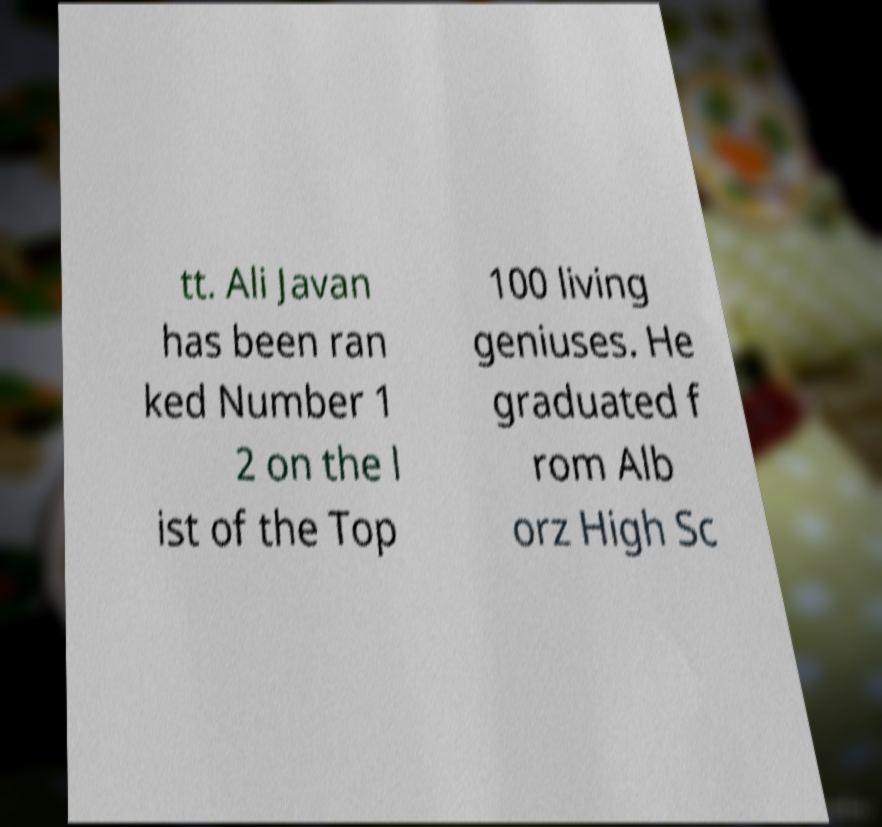Can you accurately transcribe the text from the provided image for me? tt. Ali Javan has been ran ked Number 1 2 on the l ist of the Top 100 living geniuses. He graduated f rom Alb orz High Sc 